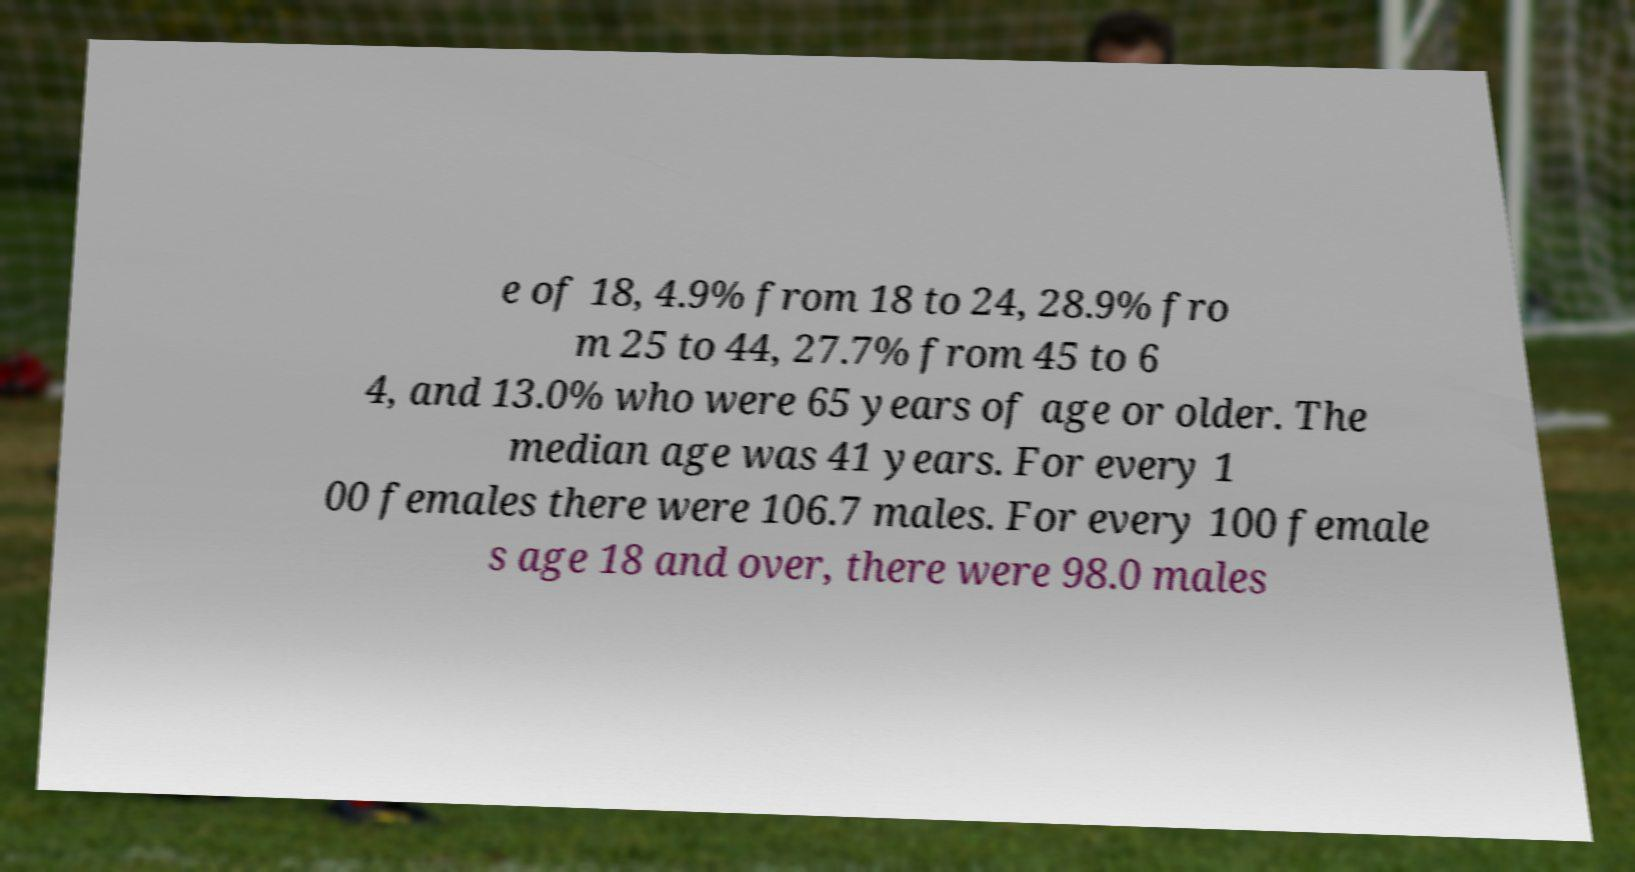For documentation purposes, I need the text within this image transcribed. Could you provide that? e of 18, 4.9% from 18 to 24, 28.9% fro m 25 to 44, 27.7% from 45 to 6 4, and 13.0% who were 65 years of age or older. The median age was 41 years. For every 1 00 females there were 106.7 males. For every 100 female s age 18 and over, there were 98.0 males 